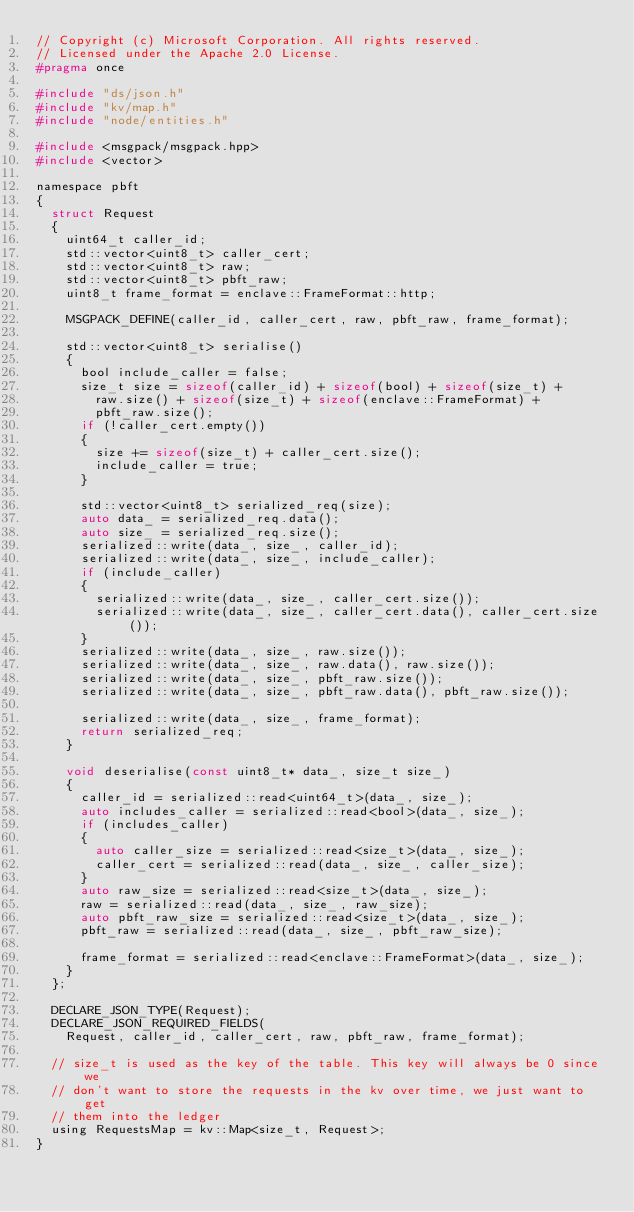<code> <loc_0><loc_0><loc_500><loc_500><_C_>// Copyright (c) Microsoft Corporation. All rights reserved.
// Licensed under the Apache 2.0 License.
#pragma once

#include "ds/json.h"
#include "kv/map.h"
#include "node/entities.h"

#include <msgpack/msgpack.hpp>
#include <vector>

namespace pbft
{
  struct Request
  {
    uint64_t caller_id;
    std::vector<uint8_t> caller_cert;
    std::vector<uint8_t> raw;
    std::vector<uint8_t> pbft_raw;
    uint8_t frame_format = enclave::FrameFormat::http;

    MSGPACK_DEFINE(caller_id, caller_cert, raw, pbft_raw, frame_format);

    std::vector<uint8_t> serialise()
    {
      bool include_caller = false;
      size_t size = sizeof(caller_id) + sizeof(bool) + sizeof(size_t) +
        raw.size() + sizeof(size_t) + sizeof(enclave::FrameFormat) +
        pbft_raw.size();
      if (!caller_cert.empty())
      {
        size += sizeof(size_t) + caller_cert.size();
        include_caller = true;
      }

      std::vector<uint8_t> serialized_req(size);
      auto data_ = serialized_req.data();
      auto size_ = serialized_req.size();
      serialized::write(data_, size_, caller_id);
      serialized::write(data_, size_, include_caller);
      if (include_caller)
      {
        serialized::write(data_, size_, caller_cert.size());
        serialized::write(data_, size_, caller_cert.data(), caller_cert.size());
      }
      serialized::write(data_, size_, raw.size());
      serialized::write(data_, size_, raw.data(), raw.size());
      serialized::write(data_, size_, pbft_raw.size());
      serialized::write(data_, size_, pbft_raw.data(), pbft_raw.size());

      serialized::write(data_, size_, frame_format);
      return serialized_req;
    }

    void deserialise(const uint8_t* data_, size_t size_)
    {
      caller_id = serialized::read<uint64_t>(data_, size_);
      auto includes_caller = serialized::read<bool>(data_, size_);
      if (includes_caller)
      {
        auto caller_size = serialized::read<size_t>(data_, size_);
        caller_cert = serialized::read(data_, size_, caller_size);
      }
      auto raw_size = serialized::read<size_t>(data_, size_);
      raw = serialized::read(data_, size_, raw_size);
      auto pbft_raw_size = serialized::read<size_t>(data_, size_);
      pbft_raw = serialized::read(data_, size_, pbft_raw_size);

      frame_format = serialized::read<enclave::FrameFormat>(data_, size_);
    }
  };

  DECLARE_JSON_TYPE(Request);
  DECLARE_JSON_REQUIRED_FIELDS(
    Request, caller_id, caller_cert, raw, pbft_raw, frame_format);

  // size_t is used as the key of the table. This key will always be 0 since we
  // don't want to store the requests in the kv over time, we just want to get
  // them into the ledger
  using RequestsMap = kv::Map<size_t, Request>;
}</code> 